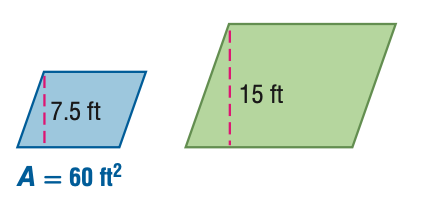Answer the mathemtical geometry problem and directly provide the correct option letter.
Question: For the pair of similar figures, find the area of the green figure.
Choices: A: 15 B: 30 C: 120 D: 240 D 